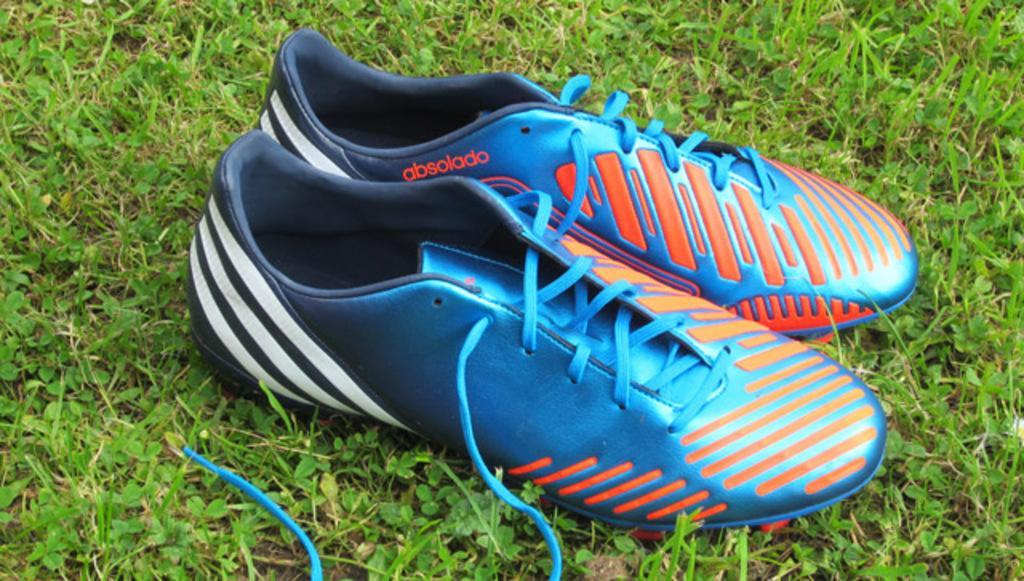How would you summarize this image in a sentence or two? In this image we can see shoes which are placed on the grass. 